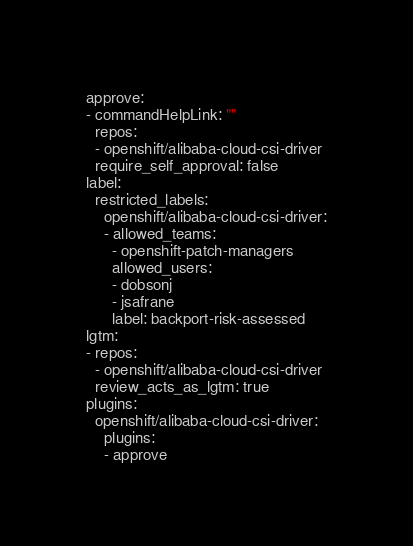Convert code to text. <code><loc_0><loc_0><loc_500><loc_500><_YAML_>approve:
- commandHelpLink: ""
  repos:
  - openshift/alibaba-cloud-csi-driver
  require_self_approval: false
label:
  restricted_labels:
    openshift/alibaba-cloud-csi-driver:
    - allowed_teams:
      - openshift-patch-managers
      allowed_users:
      - dobsonj
      - jsafrane
      label: backport-risk-assessed
lgtm:
- repos:
  - openshift/alibaba-cloud-csi-driver
  review_acts_as_lgtm: true
plugins:
  openshift/alibaba-cloud-csi-driver:
    plugins:
    - approve
</code> 